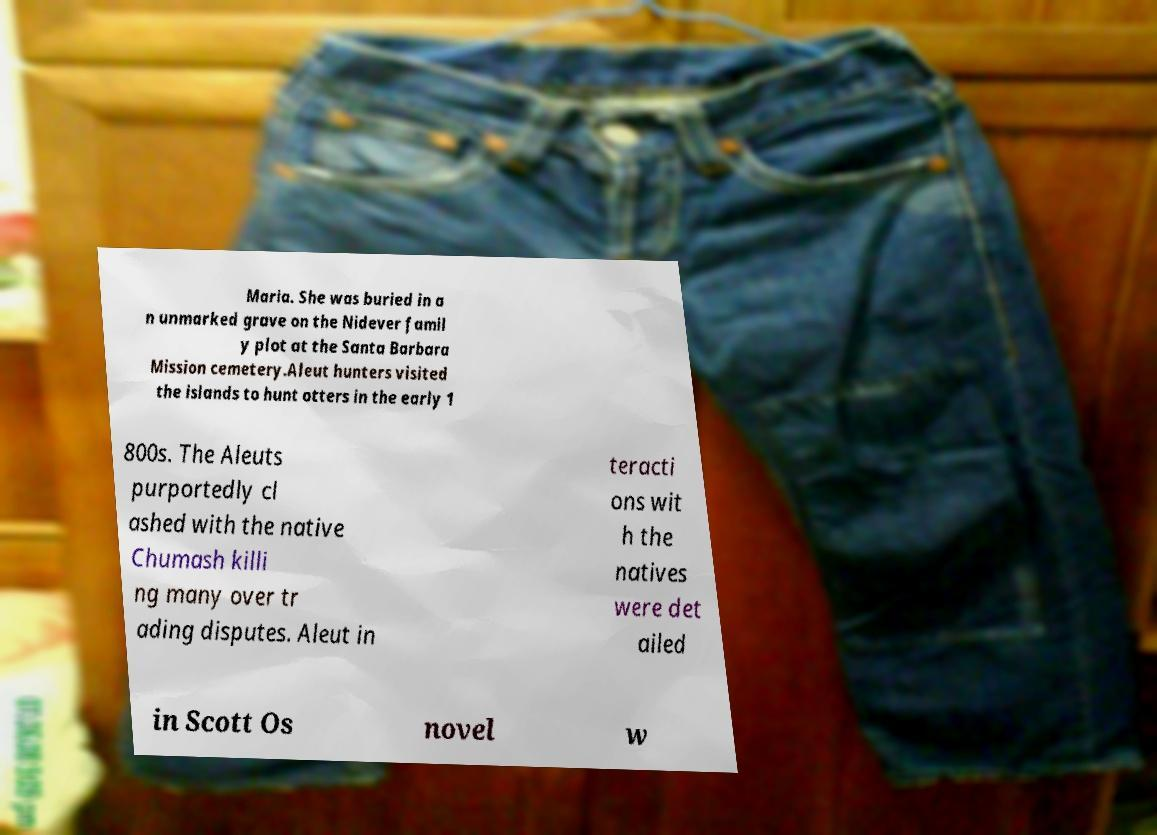Could you extract and type out the text from this image? Maria. She was buried in a n unmarked grave on the Nidever famil y plot at the Santa Barbara Mission cemetery.Aleut hunters visited the islands to hunt otters in the early 1 800s. The Aleuts purportedly cl ashed with the native Chumash killi ng many over tr ading disputes. Aleut in teracti ons wit h the natives were det ailed in Scott Os novel w 